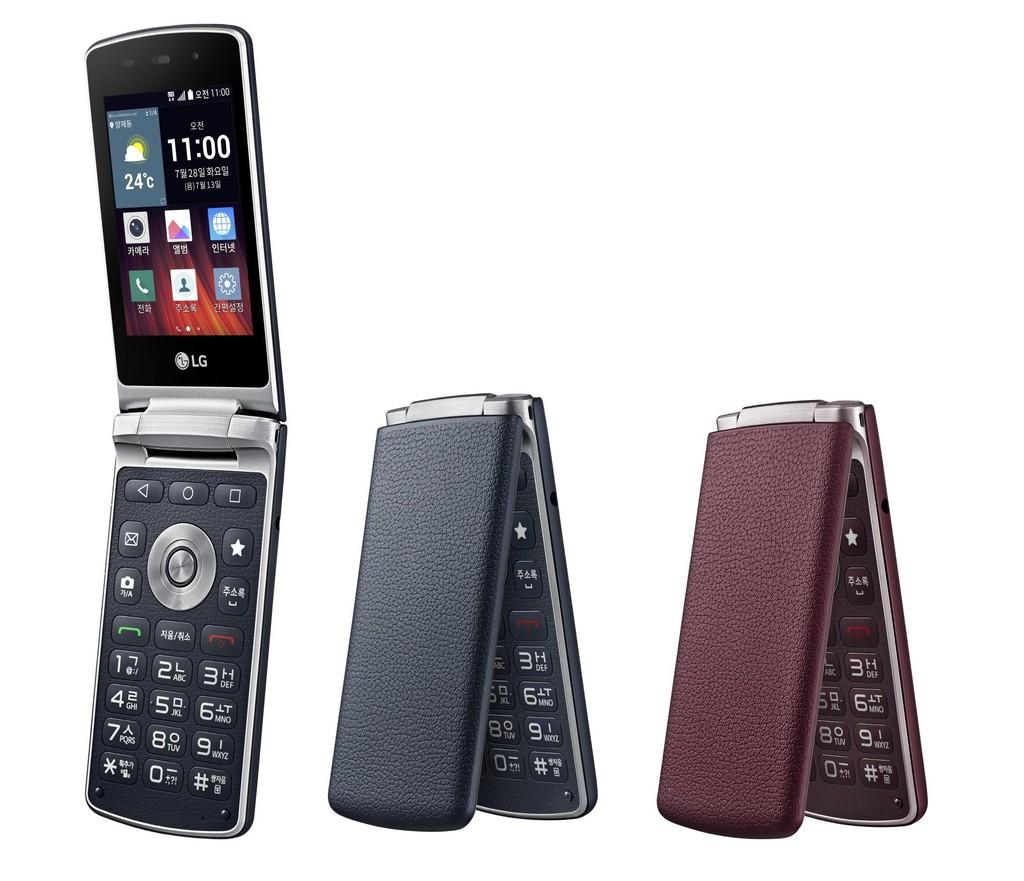Provide a one-sentence caption for the provided image. Cellphone by LG with the time set at 11:00. 